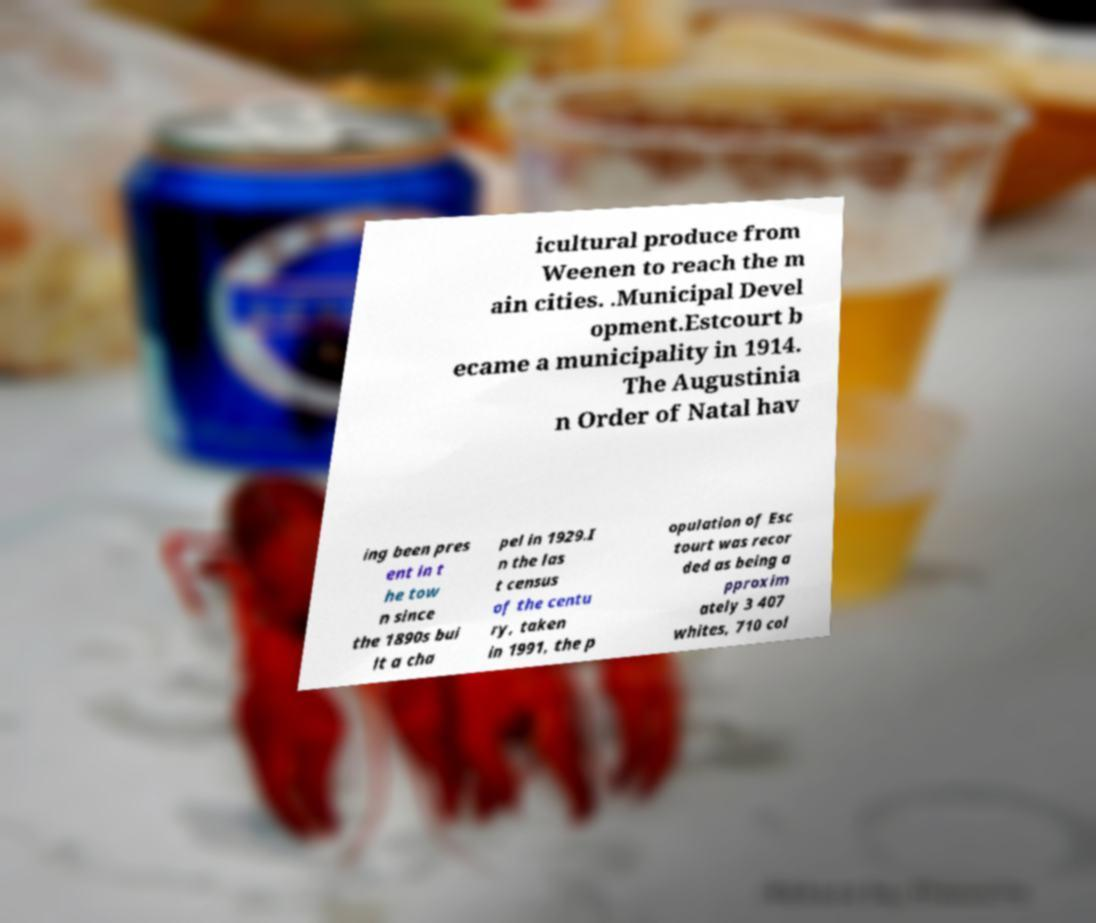Can you read and provide the text displayed in the image?This photo seems to have some interesting text. Can you extract and type it out for me? icultural produce from Weenen to reach the m ain cities. .Municipal Devel opment.Estcourt b ecame a municipality in 1914. The Augustinia n Order of Natal hav ing been pres ent in t he tow n since the 1890s bui lt a cha pel in 1929.I n the las t census of the centu ry, taken in 1991, the p opulation of Esc tourt was recor ded as being a pproxim ately 3 407 whites, 710 col 